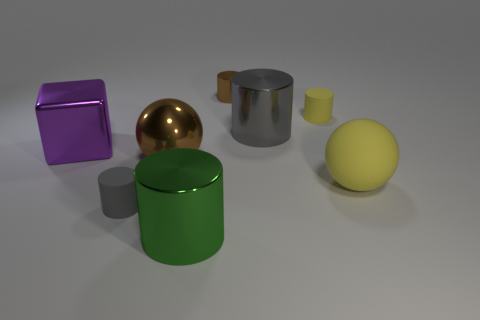Subtract all tiny metal cylinders. How many cylinders are left? 4 Subtract all blue cylinders. Subtract all yellow blocks. How many cylinders are left? 5 Add 1 small red matte balls. How many objects exist? 9 Subtract all blocks. How many objects are left? 7 Subtract all tiny brown metallic cylinders. Subtract all metallic blocks. How many objects are left? 6 Add 3 gray matte things. How many gray matte things are left? 4 Add 6 gray metallic things. How many gray metallic things exist? 7 Subtract 1 yellow cylinders. How many objects are left? 7 